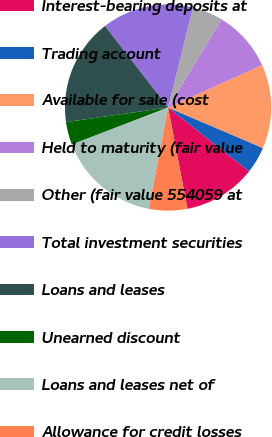<chart> <loc_0><loc_0><loc_500><loc_500><pie_chart><fcel>Interest-bearing deposits at<fcel>Trading account<fcel>Available for sale (cost<fcel>Held to maturity (fair value<fcel>Other (fair value 554059 at<fcel>Total investment securities<fcel>Loans and leases<fcel>Unearned discount<fcel>Loans and leases net of<fcel>Allowance for credit losses<nl><fcel>11.38%<fcel>4.19%<fcel>13.17%<fcel>9.58%<fcel>4.79%<fcel>14.37%<fcel>16.77%<fcel>3.59%<fcel>16.17%<fcel>5.99%<nl></chart> 